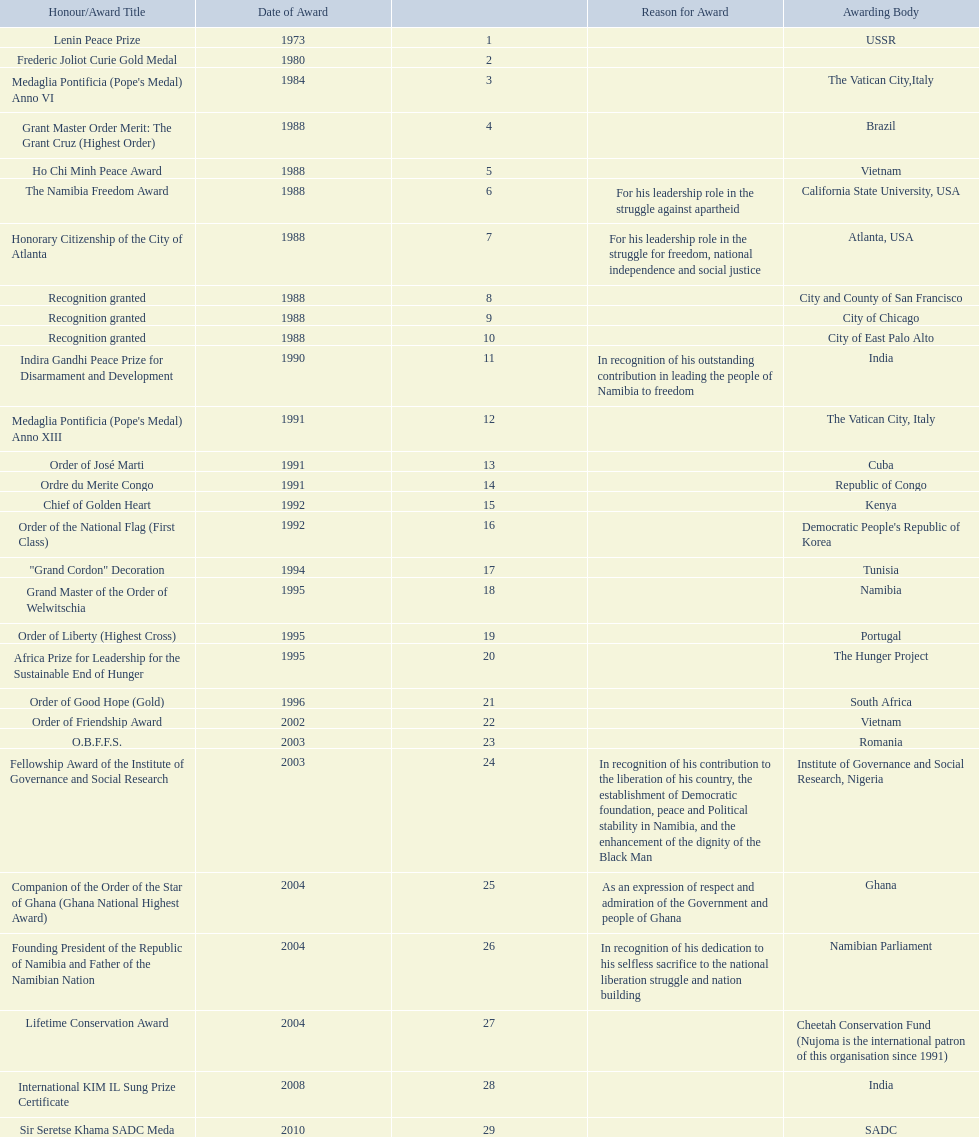What awards did sam nujoma win? 1, 1973, Lenin Peace Prize, Frederic Joliot Curie Gold Medal, Medaglia Pontificia (Pope's Medal) Anno VI, Grant Master Order Merit: The Grant Cruz (Highest Order), Ho Chi Minh Peace Award, The Namibia Freedom Award, Honorary Citizenship of the City of Atlanta, Recognition granted, Recognition granted, Recognition granted, Indira Gandhi Peace Prize for Disarmament and Development, Medaglia Pontificia (Pope's Medal) Anno XIII, Order of José Marti, Ordre du Merite Congo, Chief of Golden Heart, Order of the National Flag (First Class), "Grand Cordon" Decoration, Grand Master of the Order of Welwitschia, Order of Liberty (Highest Cross), Africa Prize for Leadership for the Sustainable End of Hunger, Order of Good Hope (Gold), Order of Friendship Award, O.B.F.F.S., Fellowship Award of the Institute of Governance and Social Research, Companion of the Order of the Star of Ghana (Ghana National Highest Award), Founding President of the Republic of Namibia and Father of the Namibian Nation, Lifetime Conservation Award, International KIM IL Sung Prize Certificate, Sir Seretse Khama SADC Meda. Who was the awarding body for the o.b.f.f.s award? Romania. 